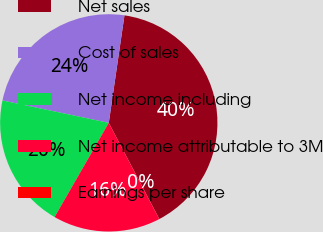Convert chart to OTSL. <chart><loc_0><loc_0><loc_500><loc_500><pie_chart><fcel>Net sales<fcel>Cost of sales<fcel>Net income including<fcel>Net income attributable to 3M<fcel>Earnings per share<nl><fcel>39.99%<fcel>24.0%<fcel>20.0%<fcel>16.0%<fcel>0.01%<nl></chart> 